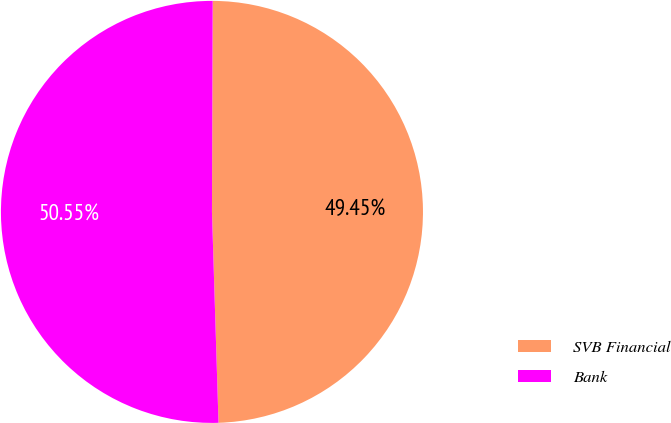Convert chart to OTSL. <chart><loc_0><loc_0><loc_500><loc_500><pie_chart><fcel>SVB Financial<fcel>Bank<nl><fcel>49.45%<fcel>50.55%<nl></chart> 